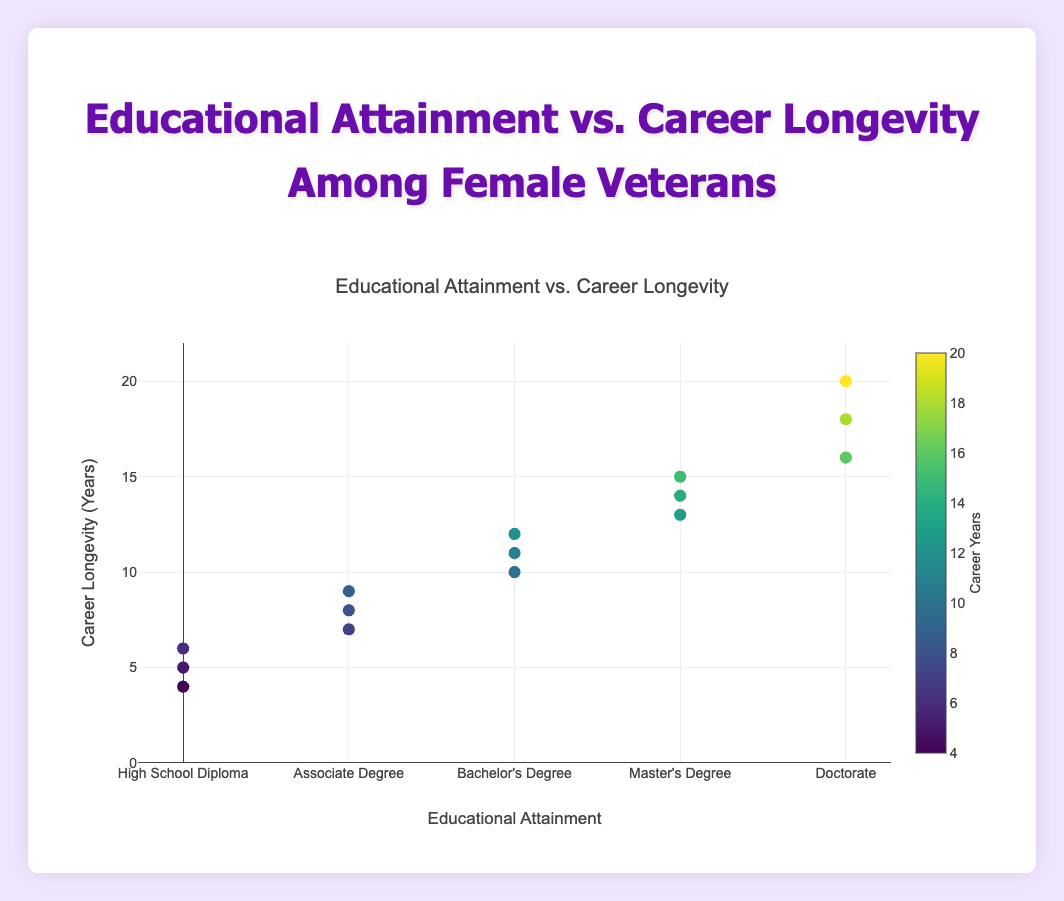How many educational levels are displayed in the figure? There are five distinct educational levels visible on the x-axis: "High School Diploma", "Associate Degree", "Bachelor's Degree", "Master's Degree", and "Doctorate".
Answer: Five What is the educational attainment of the person with the longest career longevity? By looking at the highest y-value on the scatter plot, the person with the longest career longevity (20 years) has a "Doctorate" as their educational attainment.
Answer: Doctorate What is the range of career longevity in the dataset? The range can be found by identifying the minimum and maximum y-values. The minimum career longevity is 4 years and the maximum is 20 years. Therefore, the range is 20 - 4 = 16 years.
Answer: 16 years What is the average career longevity for those with a Bachelor's Degree? Looking at the points mapped to "Bachelor's Degree": 12, 10, and 11 years. The sum is 33 years. The average is 33 / 3 = 11 years.
Answer: 11 years Is there a visual trend indicating higher educational attainment correlates with longer career longevity? Observing the scatter plot, points corresponding to higher educational attainments (like Master's Degree and Doctorate) tend to be positioned higher on the y-axis, indicating longer career longevity. This suggests a positive correlation between higher education and career length.
Answer: Yes Which educational category has the highest number of data points? By counting the points at each x-axis category, "Bachelor's Degree" has the highest number with three data points.
Answer: Bachelor's Degree Are there more data points above or below 10 career years? By counting the points, there are 8 data points above 10 years and 7 data points below 10 years.
Answer: Above What is the difference in career longevity between the highest and lowest individuals in the "Master's Degree" category? In the Master's Degree category, the highest career longevity is 15 years (Emily Brown) and the lowest is 13 years (Margaret Lewis), so the difference is 15 - 13 = 2 years.
Answer: 2 years Which individual has the shortest career longevity and what is their education level? The individual with the shortest career longevity (4 years) is Nancy Hall with a "High School Diploma".
Answer: Nancy Hall with High School Diploma 